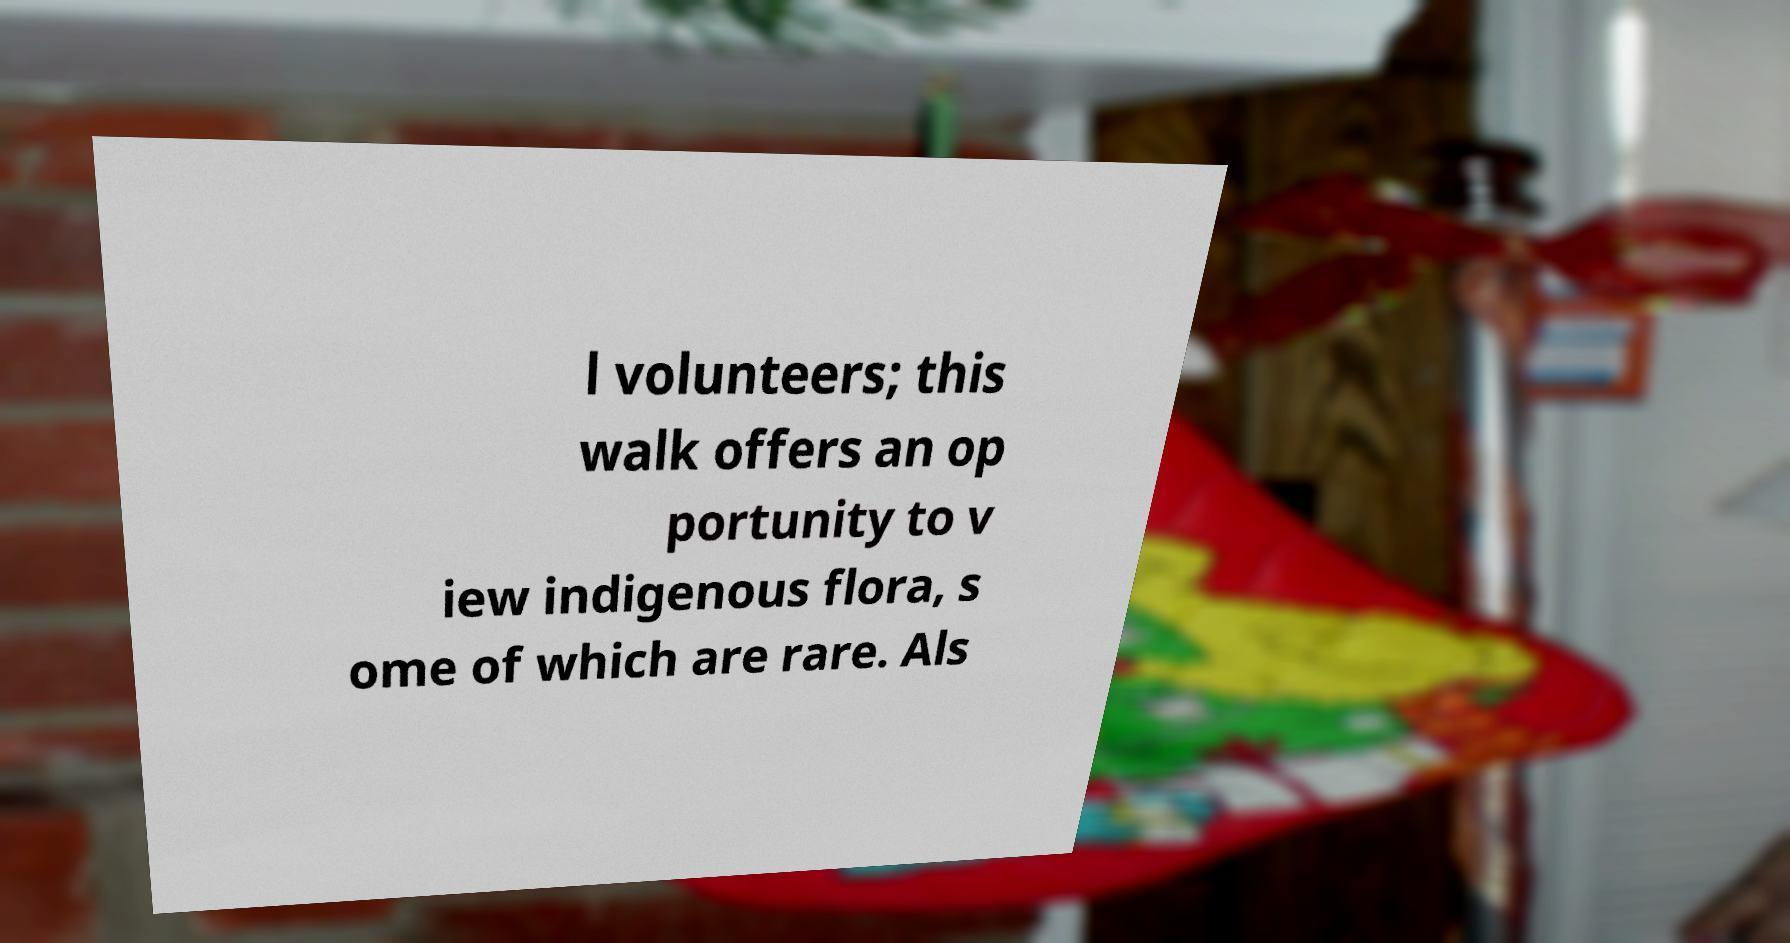Please identify and transcribe the text found in this image. l volunteers; this walk offers an op portunity to v iew indigenous flora, s ome of which are rare. Als 